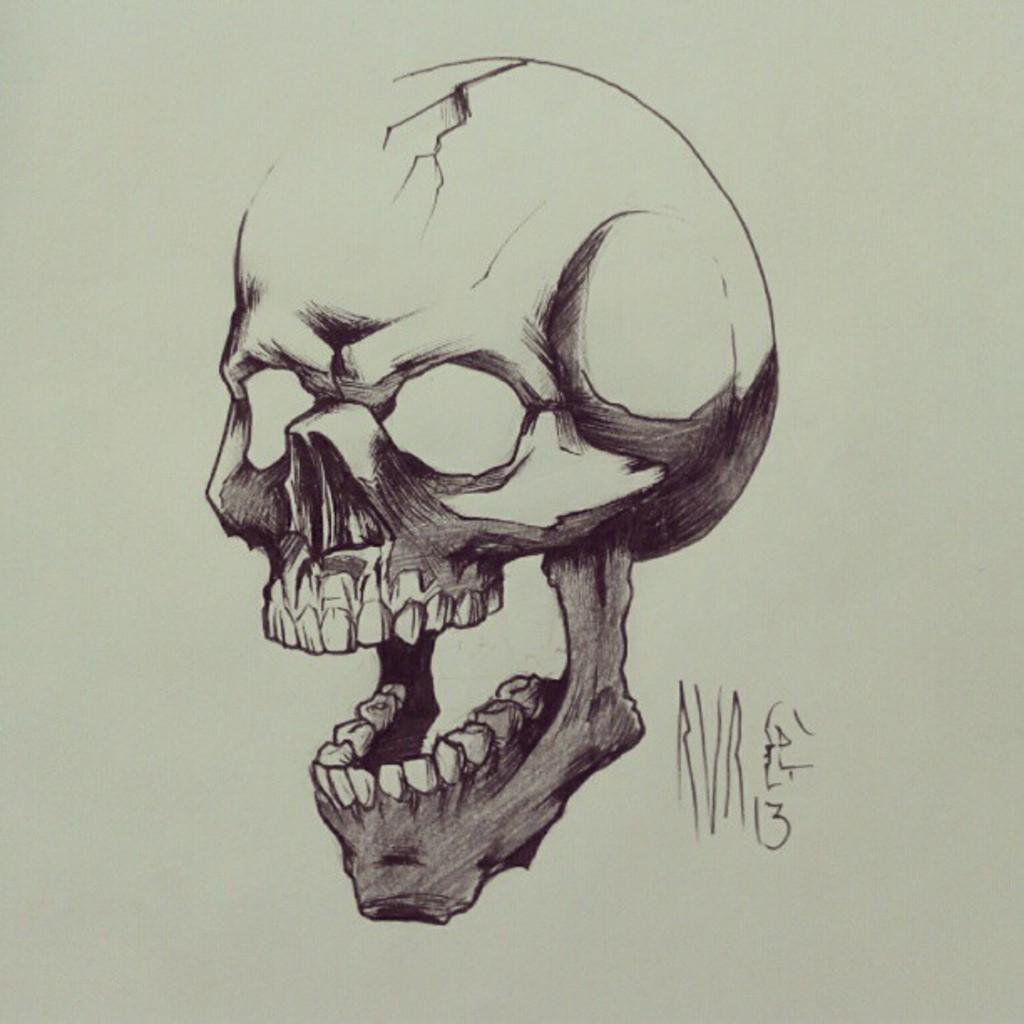What is the main subject of the drawing in the image? The main subject of the drawing in the image is a skull. Are there any additional features on the skull? Yes, the skull has a group of teeth attached to it. What type of throne is the skull sitting on in the image? There is no throne present in the image; it only features a drawing of a skull with teeth attached to it. 